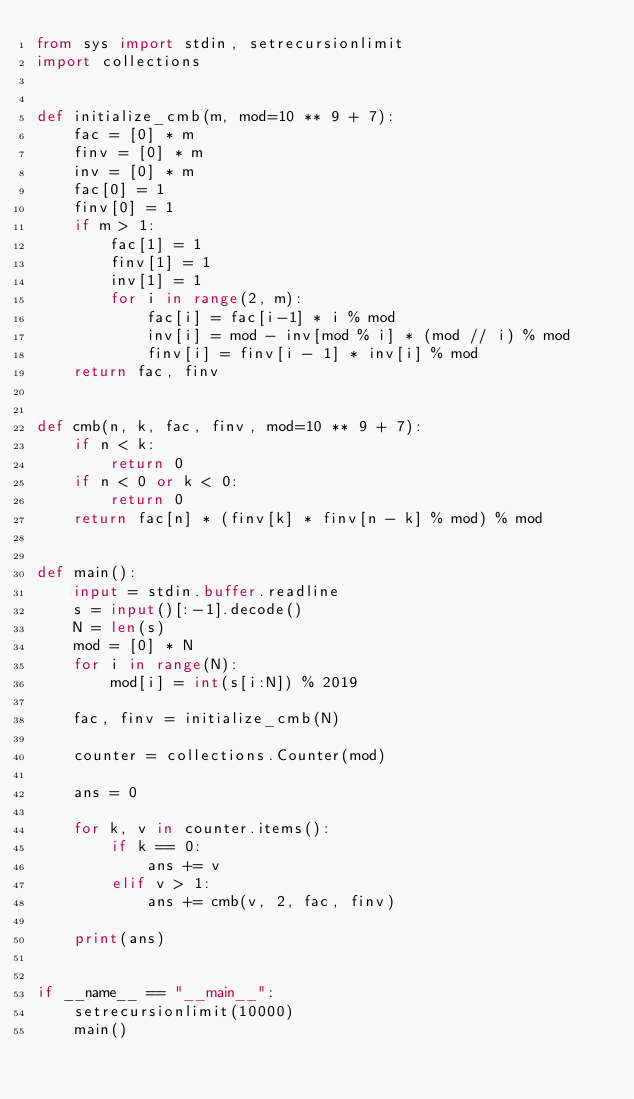Convert code to text. <code><loc_0><loc_0><loc_500><loc_500><_Python_>from sys import stdin, setrecursionlimit
import collections


def initialize_cmb(m, mod=10 ** 9 + 7):
    fac = [0] * m
    finv = [0] * m
    inv = [0] * m
    fac[0] = 1
    finv[0] = 1
    if m > 1:
        fac[1] = 1
        finv[1] = 1
        inv[1] = 1
        for i in range(2, m):
            fac[i] = fac[i-1] * i % mod
            inv[i] = mod - inv[mod % i] * (mod // i) % mod
            finv[i] = finv[i - 1] * inv[i] % mod
    return fac, finv


def cmb(n, k, fac, finv, mod=10 ** 9 + 7):
    if n < k:
        return 0
    if n < 0 or k < 0:
        return 0
    return fac[n] * (finv[k] * finv[n - k] % mod) % mod


def main():
    input = stdin.buffer.readline
    s = input()[:-1].decode()
    N = len(s)
    mod = [0] * N
    for i in range(N):
        mod[i] = int(s[i:N]) % 2019

    fac, finv = initialize_cmb(N)

    counter = collections.Counter(mod)

    ans = 0

    for k, v in counter.items():
        if k == 0:
            ans += v
        elif v > 1:
            ans += cmb(v, 2, fac, finv)

    print(ans)


if __name__ == "__main__":
    setrecursionlimit(10000)
    main()
</code> 